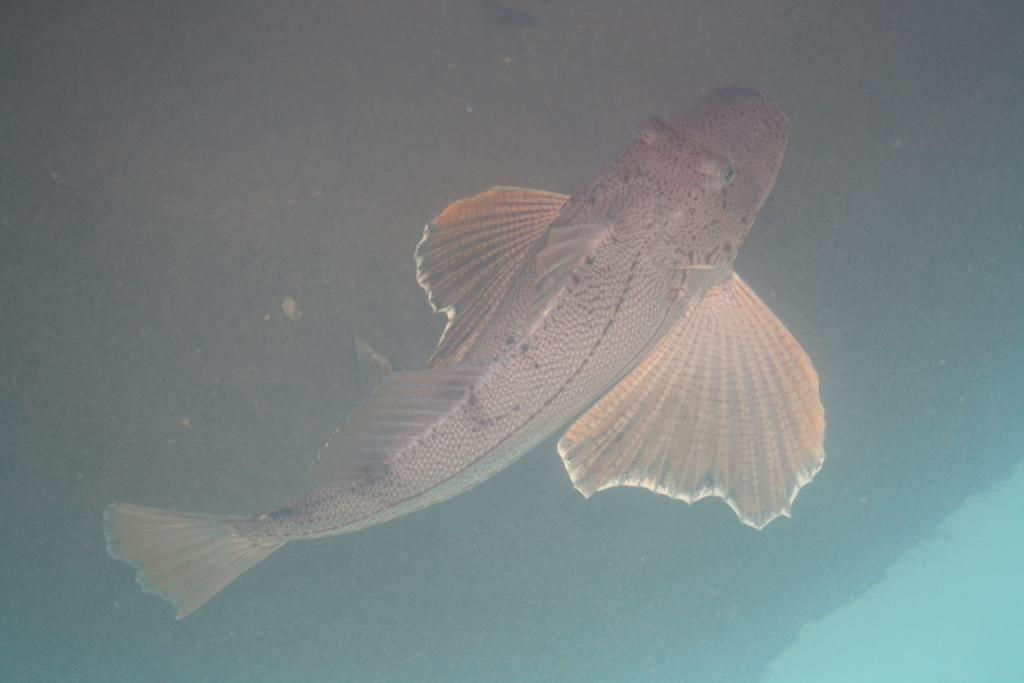What type of animal is in the image? There is a fish in the image. Where is the fish located? The fish is in the water. What flavor of wax can be seen in the image? There is no wax present in the image, so it is not possible to determine the flavor of any wax. 